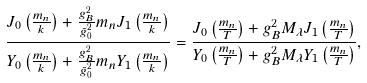Convert formula to latex. <formula><loc_0><loc_0><loc_500><loc_500>\frac { J _ { 0 } \left ( \frac { m _ { n } } { k } \right ) + \frac { g _ { B } ^ { 2 } } { \tilde { g } _ { 0 } ^ { 2 } } m _ { n } J _ { 1 } \left ( \frac { m _ { n } } { k } \right ) } { Y _ { 0 } \left ( \frac { m _ { n } } { k } \right ) + \frac { g _ { B } ^ { 2 } } { \tilde { g } _ { 0 } ^ { 2 } } m _ { n } Y _ { 1 } \left ( \frac { m _ { n } } { k } \right ) } = \frac { J _ { 0 } \left ( \frac { m _ { n } } { T } \right ) + g _ { B } ^ { 2 } M _ { \lambda } J _ { 1 } \left ( \frac { m _ { n } } { T } \right ) } { Y _ { 0 } \left ( \frac { m _ { n } } { T } \right ) + g _ { B } ^ { 2 } M _ { \lambda } Y _ { 1 } \left ( \frac { m _ { n } } { T } \right ) } ,</formula> 